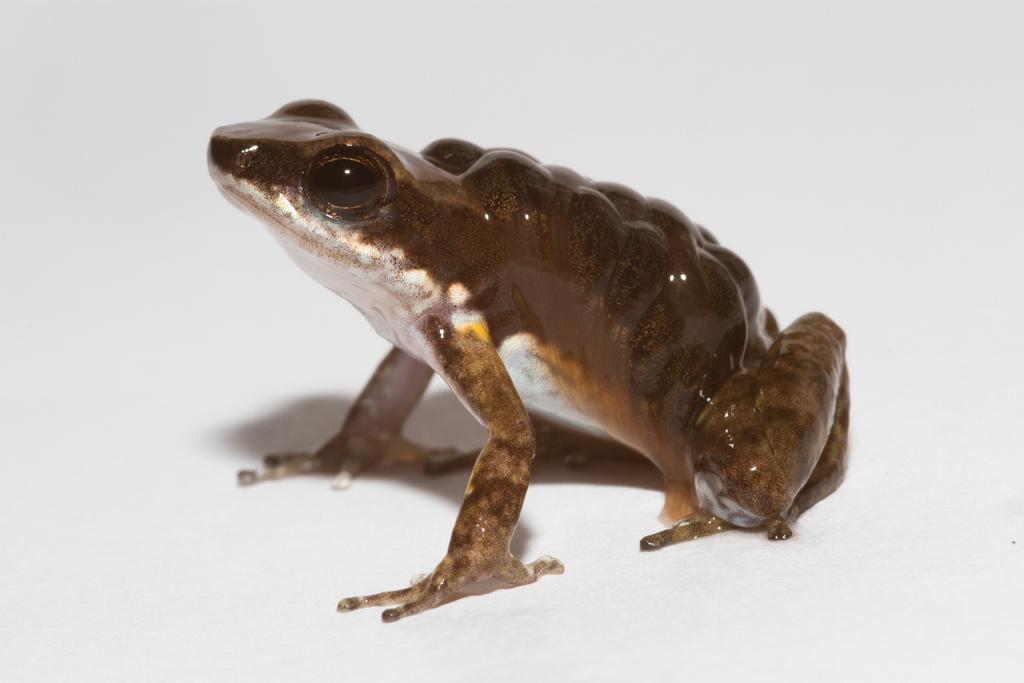Please provide a concise description of this image. There is a frog in the center of the image. 